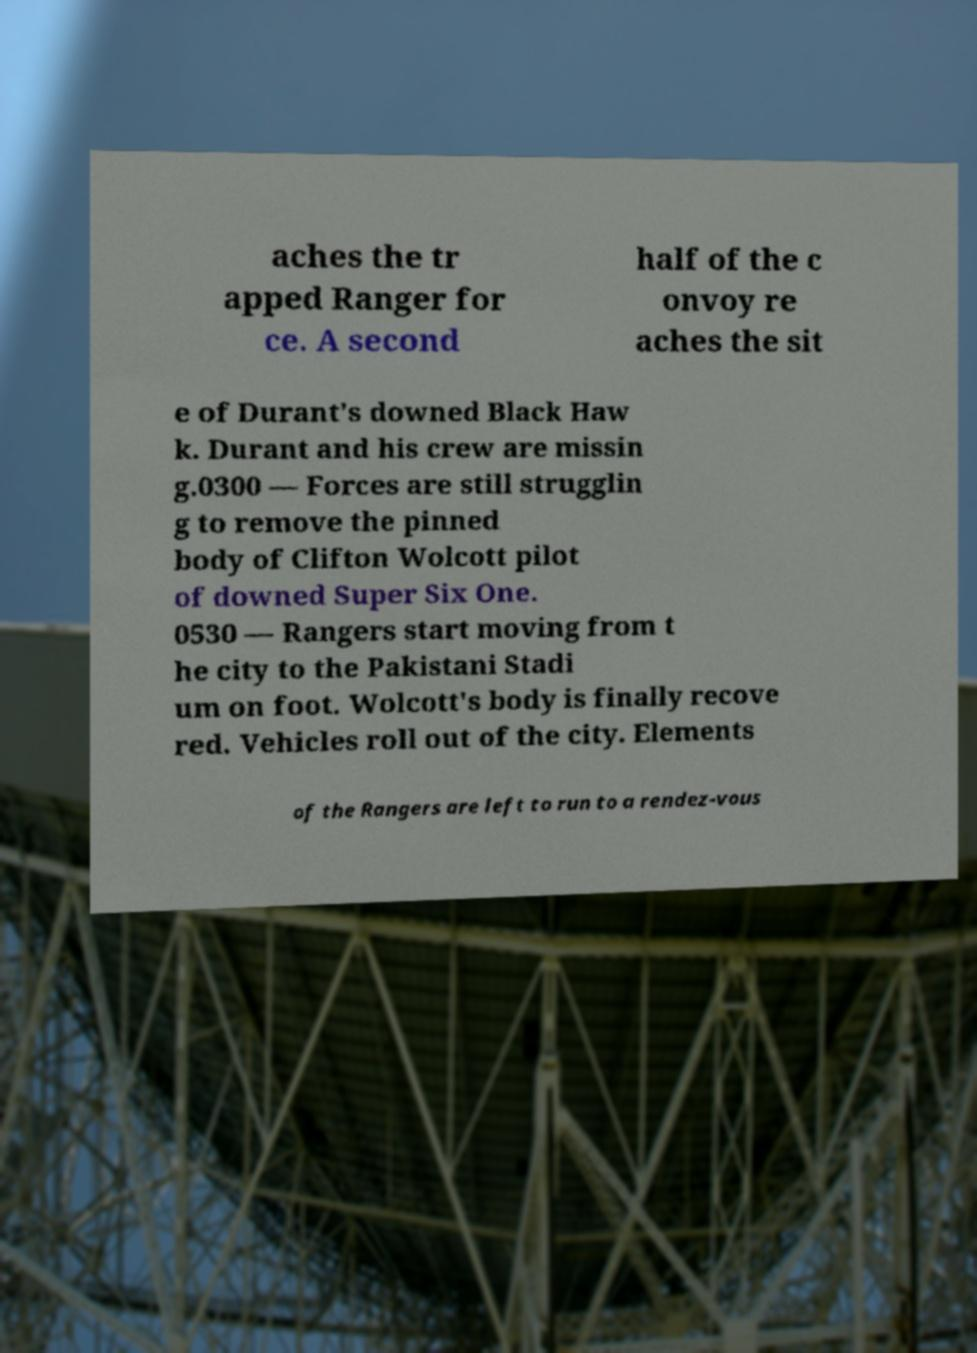There's text embedded in this image that I need extracted. Can you transcribe it verbatim? aches the tr apped Ranger for ce. A second half of the c onvoy re aches the sit e of Durant's downed Black Haw k. Durant and his crew are missin g.0300 — Forces are still strugglin g to remove the pinned body of Clifton Wolcott pilot of downed Super Six One. 0530 — Rangers start moving from t he city to the Pakistani Stadi um on foot. Wolcott's body is finally recove red. Vehicles roll out of the city. Elements of the Rangers are left to run to a rendez-vous 